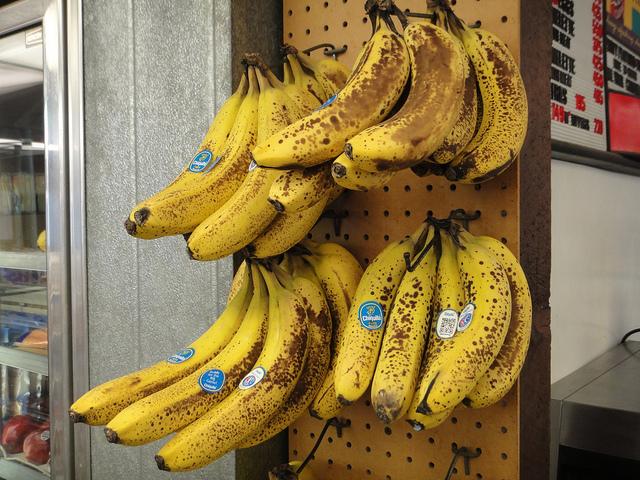How many stacks of bananas are in the photo?
Concise answer only. 4. How many bananas are there?
Answer briefly. 20. How many bananas are in the bunch?
Write a very short answer. 6. Do you eat bananas?
Write a very short answer. Yes. Is this fruit ready to be eaten?
Quick response, please. Yes. 